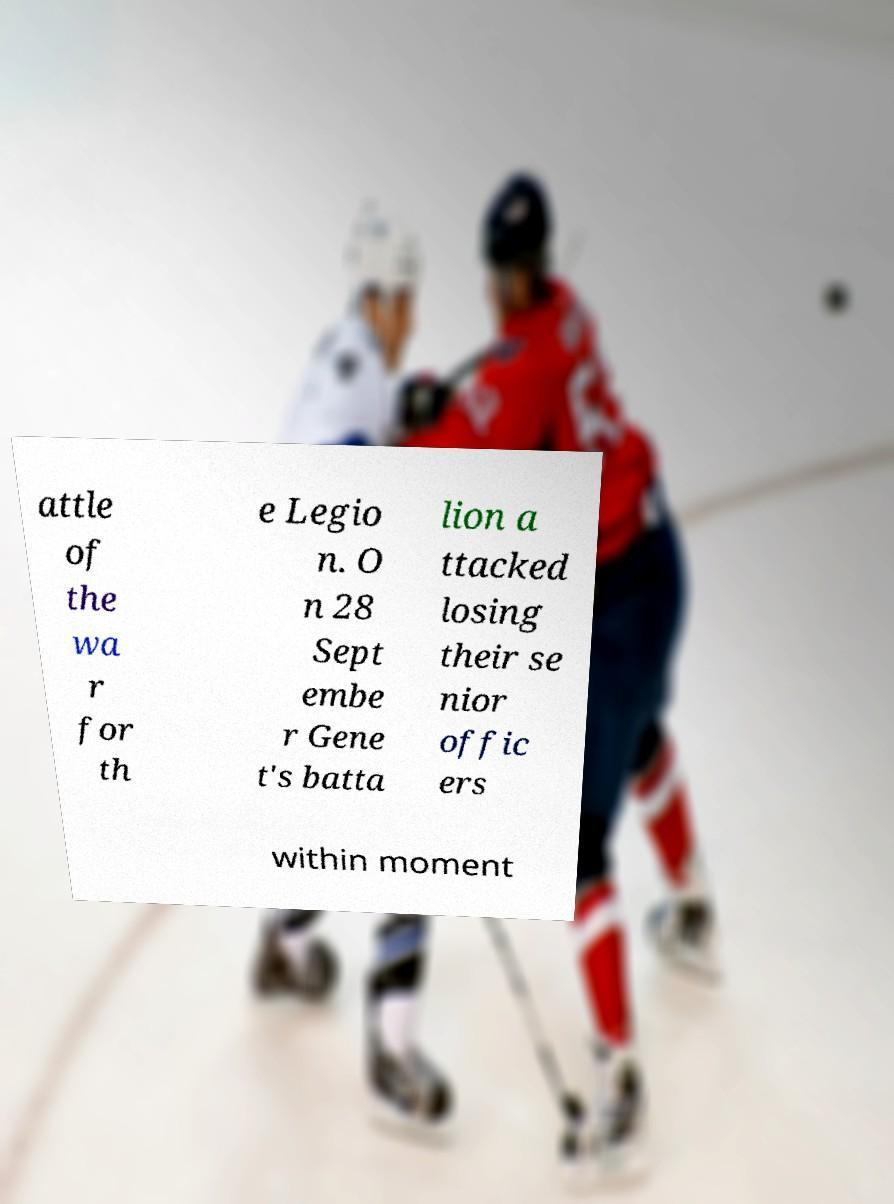Please read and relay the text visible in this image. What does it say? attle of the wa r for th e Legio n. O n 28 Sept embe r Gene t's batta lion a ttacked losing their se nior offic ers within moment 